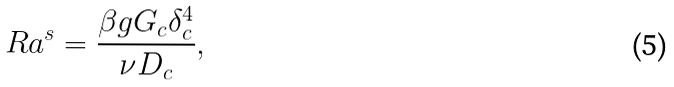Convert formula to latex. <formula><loc_0><loc_0><loc_500><loc_500>R a ^ { s } = \frac { \beta g G _ { c } \delta _ { c } ^ { 4 } } { \nu D _ { c } } ,</formula> 